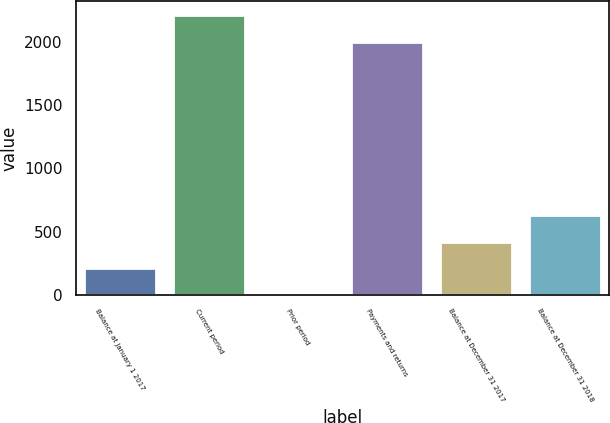Convert chart to OTSL. <chart><loc_0><loc_0><loc_500><loc_500><bar_chart><fcel>Balance at January 1 2017<fcel>Current period<fcel>Prior period<fcel>Payments and returns<fcel>Balance at December 31 2017<fcel>Balance at December 31 2018<nl><fcel>211.4<fcel>2212.4<fcel>3<fcel>2004<fcel>419.8<fcel>628.2<nl></chart> 